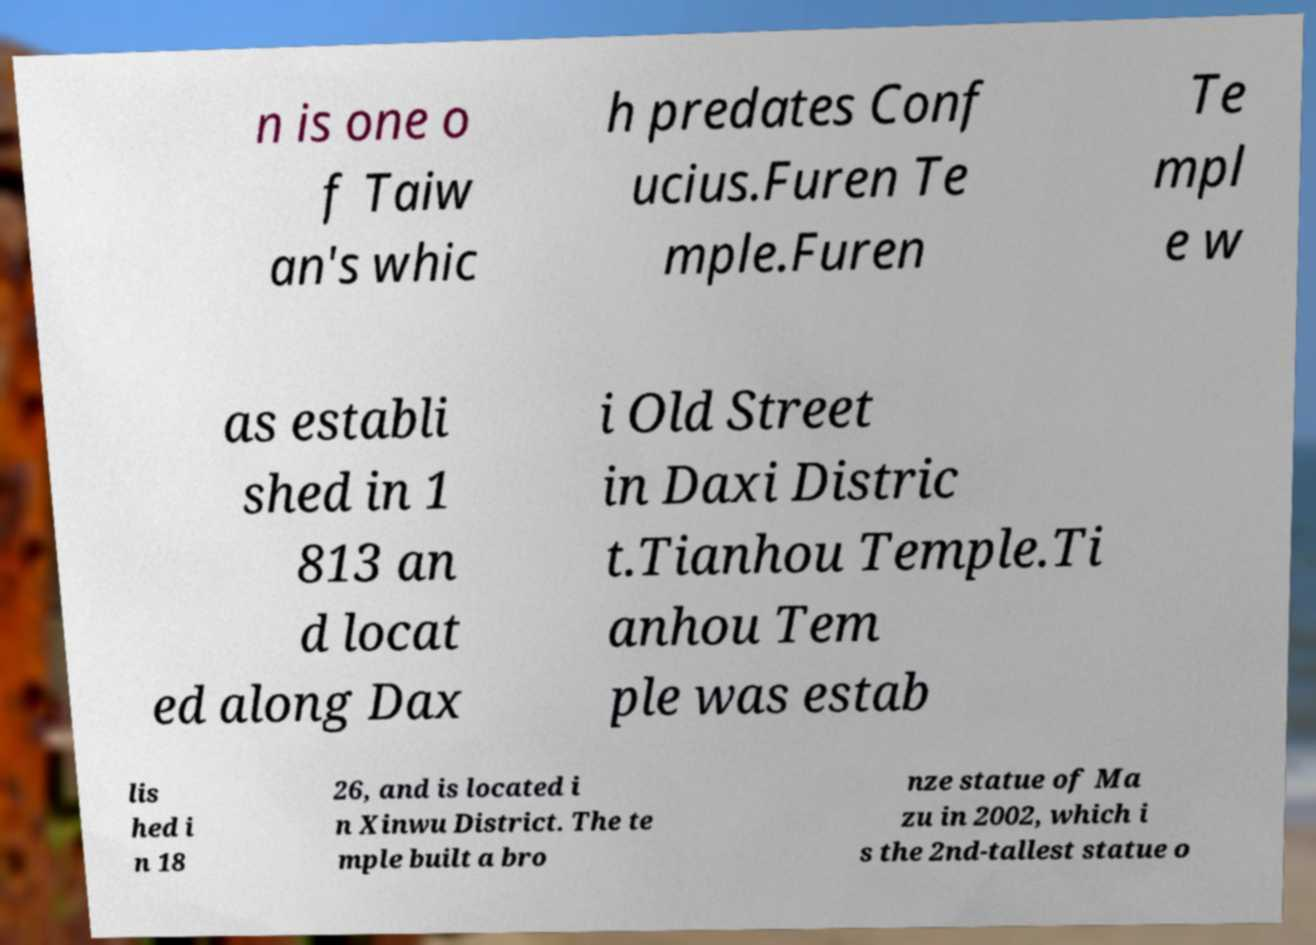Could you assist in decoding the text presented in this image and type it out clearly? n is one o f Taiw an's whic h predates Conf ucius.Furen Te mple.Furen Te mpl e w as establi shed in 1 813 an d locat ed along Dax i Old Street in Daxi Distric t.Tianhou Temple.Ti anhou Tem ple was estab lis hed i n 18 26, and is located i n Xinwu District. The te mple built a bro nze statue of Ma zu in 2002, which i s the 2nd-tallest statue o 